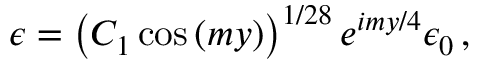<formula> <loc_0><loc_0><loc_500><loc_500>\epsilon = \left ( C _ { 1 } \cos { ( m y ) } \right ) ^ { 1 / 2 8 } e ^ { i m y / 4 } \epsilon _ { 0 } \, ,</formula> 